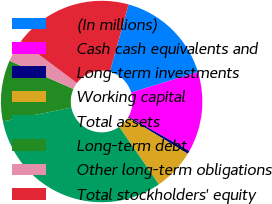Convert chart to OTSL. <chart><loc_0><loc_0><loc_500><loc_500><pie_chart><fcel>(In millions)<fcel>Cash cash equivalents and<fcel>Long-term investments<fcel>Working capital<fcel>Total assets<fcel>Long-term debt<fcel>Other long-term obligations<fcel>Total stockholders' equity<nl><fcel>15.98%<fcel>12.89%<fcel>0.5%<fcel>6.7%<fcel>31.46%<fcel>9.79%<fcel>3.6%<fcel>19.08%<nl></chart> 